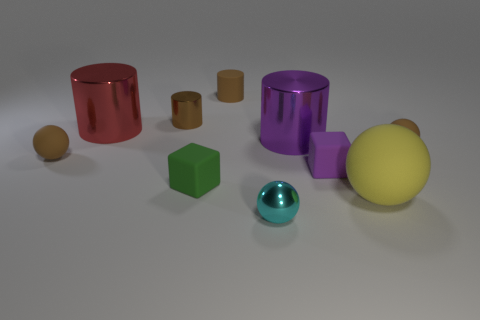Subtract all spheres. How many objects are left? 6 Subtract 0 green balls. How many objects are left? 10 Subtract all big cylinders. Subtract all tiny purple things. How many objects are left? 7 Add 4 red objects. How many red objects are left? 5 Add 8 large red matte objects. How many large red matte objects exist? 8 